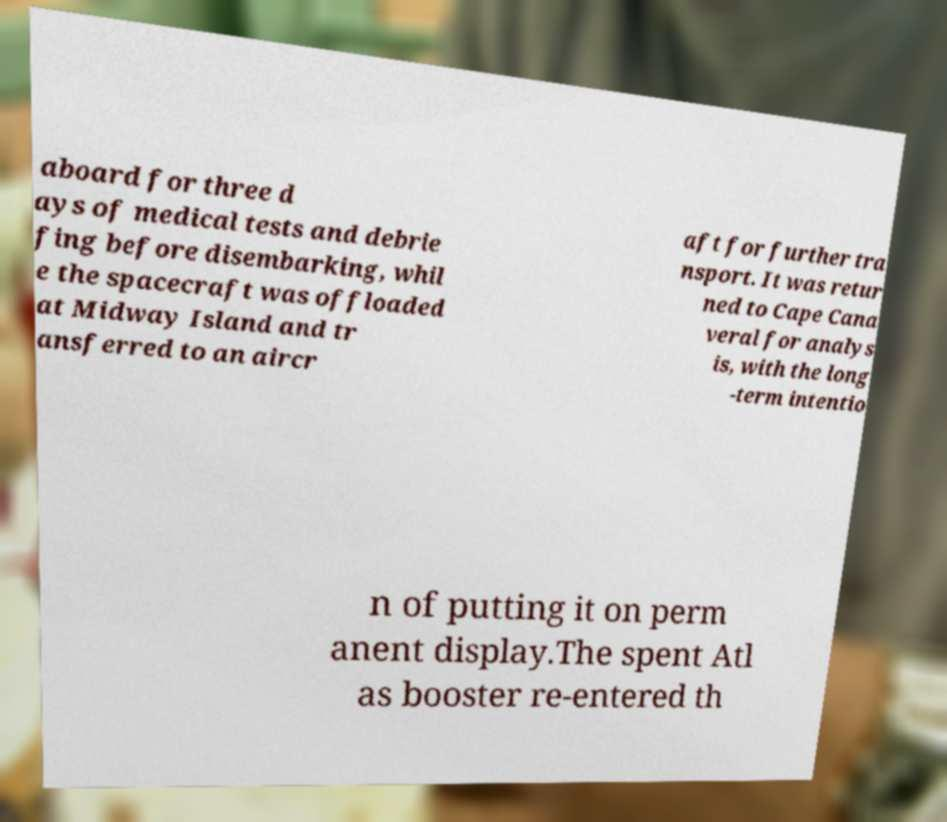What messages or text are displayed in this image? I need them in a readable, typed format. aboard for three d ays of medical tests and debrie fing before disembarking, whil e the spacecraft was offloaded at Midway Island and tr ansferred to an aircr aft for further tra nsport. It was retur ned to Cape Cana veral for analys is, with the long -term intentio n of putting it on perm anent display.The spent Atl as booster re-entered th 